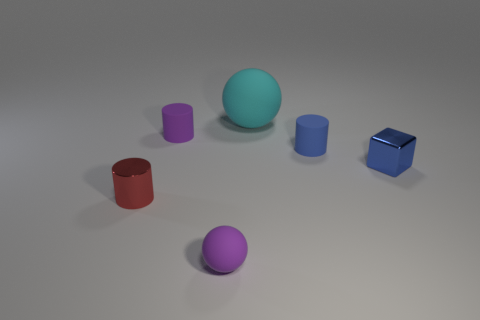There is a object that is the same color as the block; what shape is it?
Keep it short and to the point. Cylinder. How many blue cubes are the same material as the big object?
Your answer should be compact. 0. What is the color of the small cube?
Offer a terse response. Blue. There is a shiny cube that is the same size as the red thing; what color is it?
Provide a short and direct response. Blue. Is there a tiny shiny cylinder that has the same color as the tiny cube?
Ensure brevity in your answer.  No. Do the purple rubber object that is in front of the blue matte object and the shiny thing on the right side of the small sphere have the same shape?
Offer a very short reply. No. What size is the thing that is the same color as the small matte sphere?
Your response must be concise. Small. What number of other objects are there of the same size as the metallic cylinder?
Offer a very short reply. 4. Is the color of the big thing the same as the tiny matte object that is behind the blue cylinder?
Provide a succinct answer. No. Are there fewer rubber cylinders that are on the left side of the tiny red cylinder than small blue matte cylinders in front of the small ball?
Your response must be concise. No. 